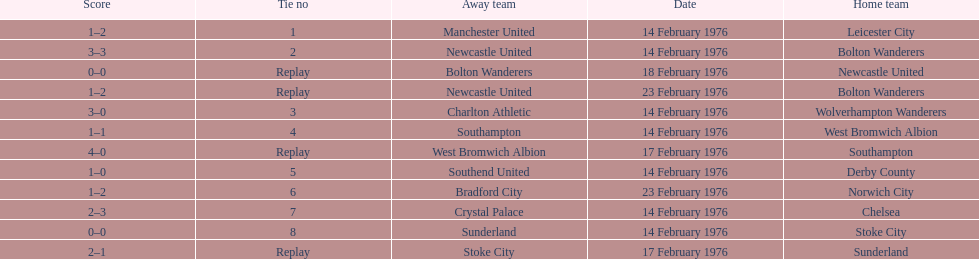How many games played by sunderland are listed here? 2. 